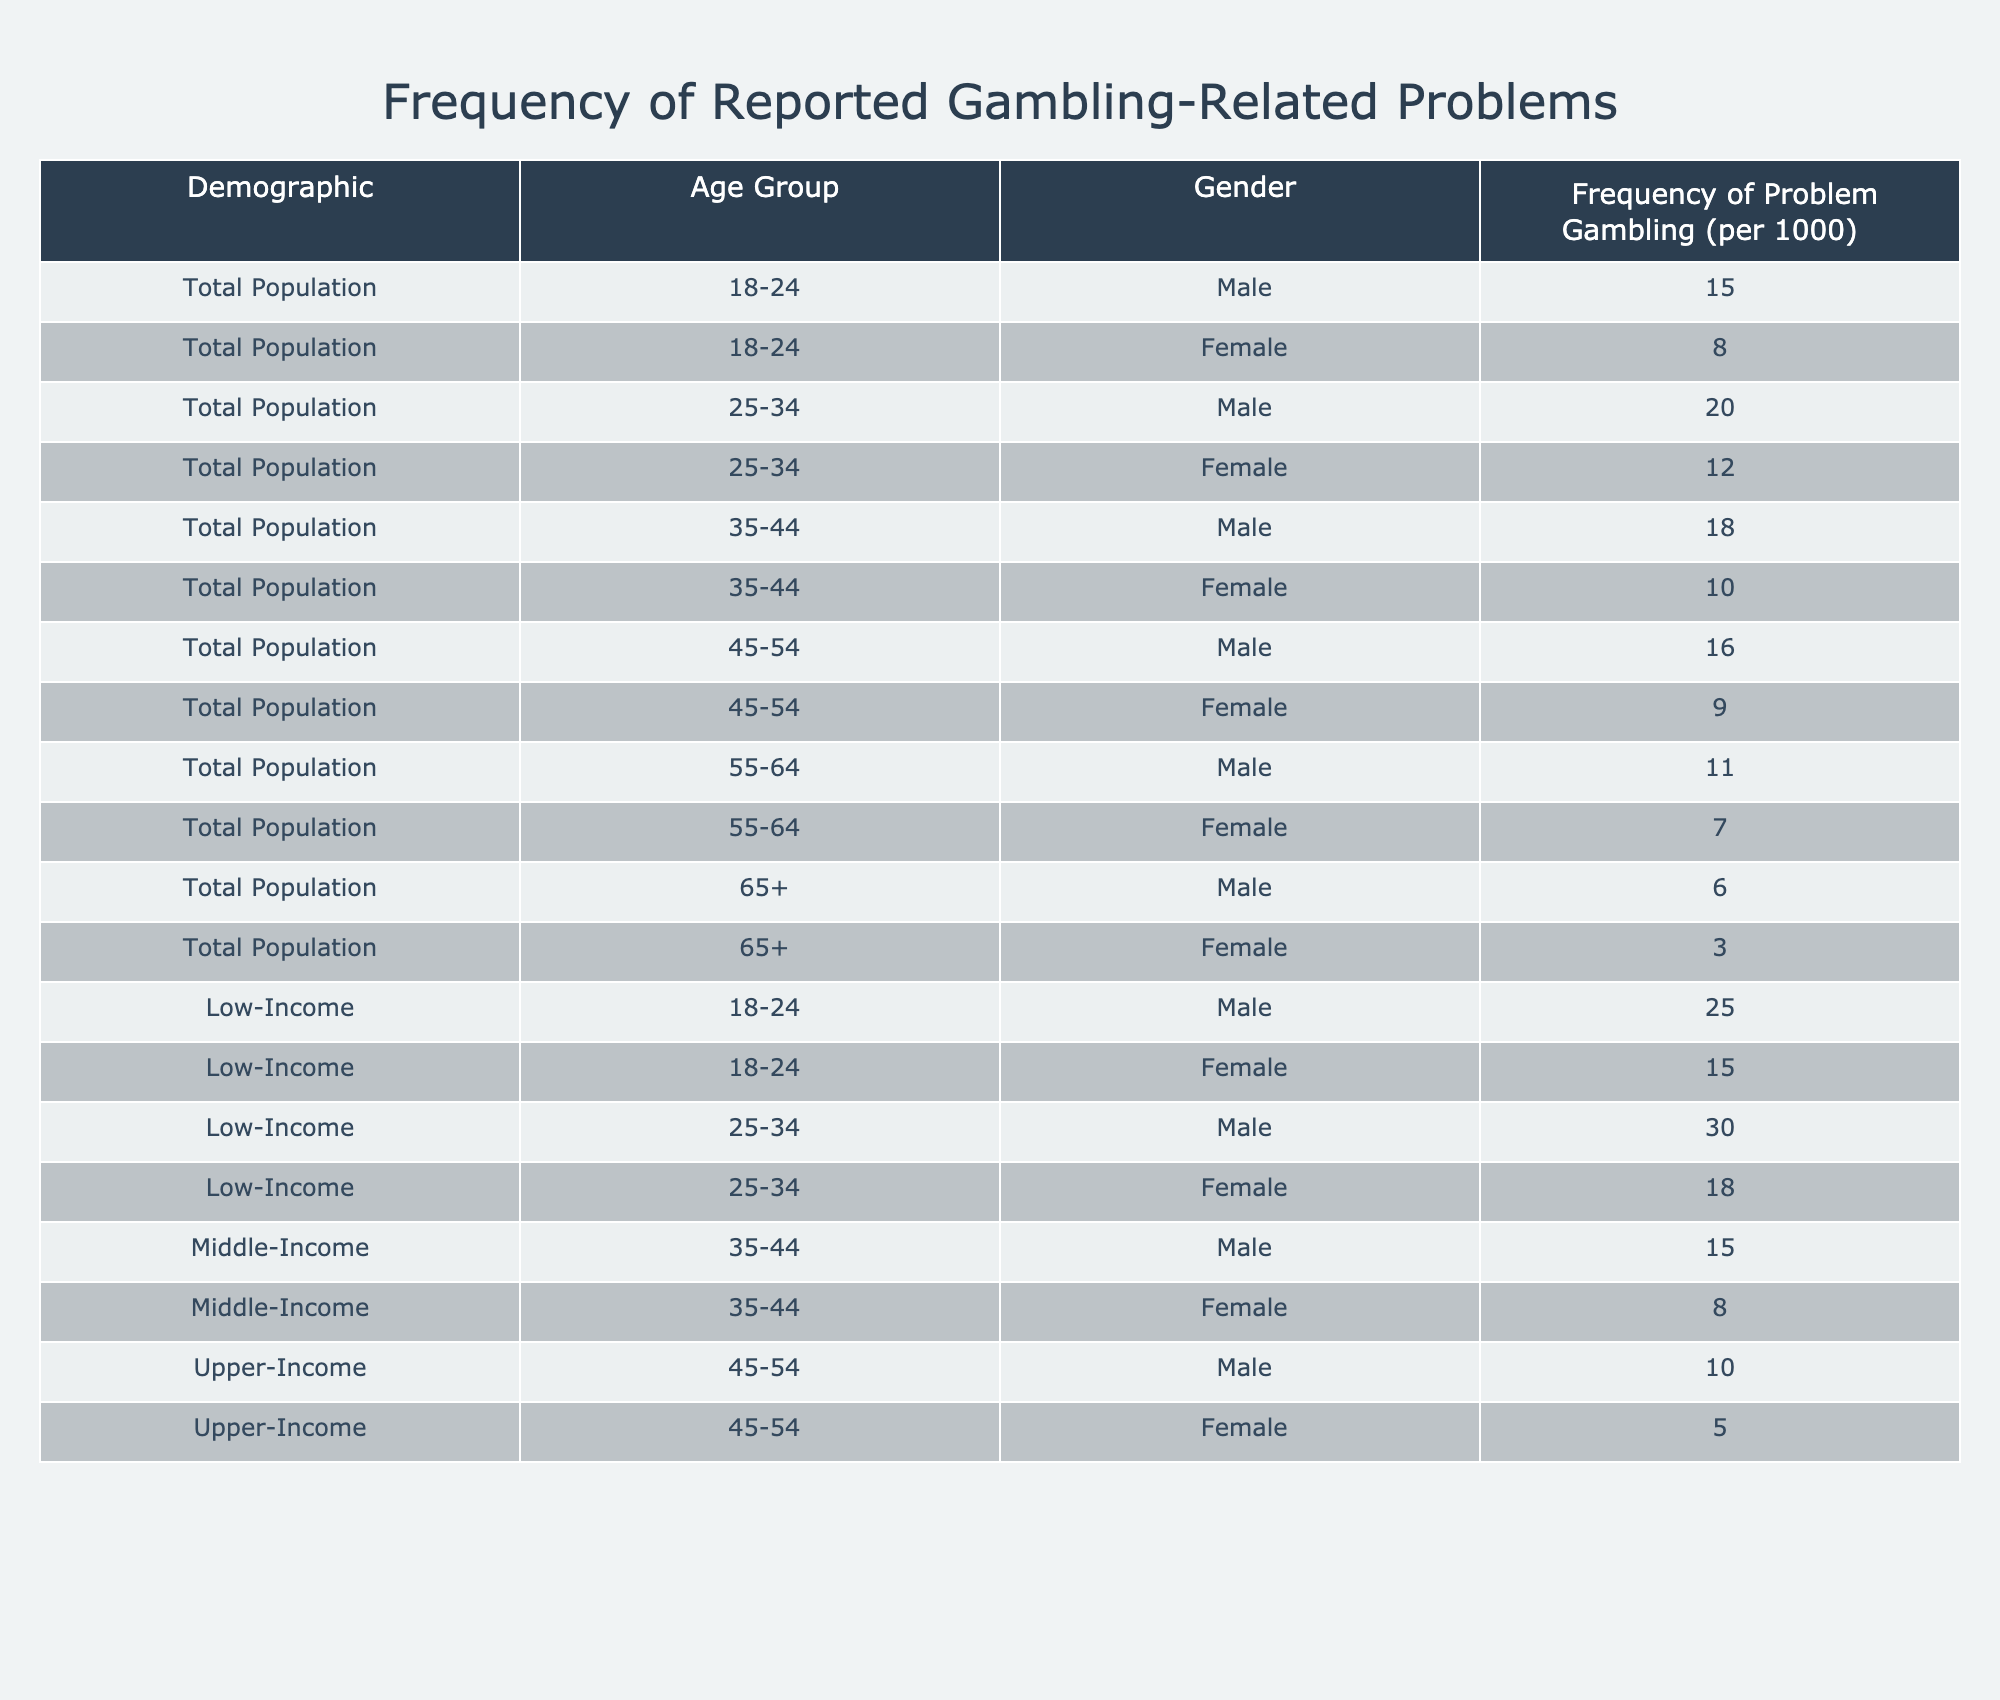What is the frequency of problem gambling among Low-Income females aged 25-34? From the table, the row corresponding to Low-Income females in the age group 25-34 shows a frequency of 18 problems per 1000 individuals.
Answer: 18 Which age group among the Total Population has the highest frequency of problem gambling for males? The age group 25-34 among the Total Population shows the highest frequency for males at 20 per 1000.
Answer: 25-34 What is the average frequency of problem gambling for Upper-Income males and females combined? For Upper-Income, the frequency for males is 10 and for females is 5. The average is calculated as (10 + 5) / 2 = 7.5.
Answer: 7.5 Is the frequency of problem gambling higher for Low-Income males or Low-Income females in the 18-24 age group? For Low-Income males aged 18-24, the frequency is 25, while for females it is 15. Thus, it is higher for males.
Answer: Yes What is the total frequency of problem gambling per 1000 for females aged 35-44 across all income levels? The frequencies for females aged 35-44 are: 10 (Total Population), 8 (Middle-Income), and no data for Low-Income and Upper-Income. Adding these gives a total of 10 + 8 = 18 per 1000.
Answer: 18 Which group has the lowest frequency of problem gambling among males aged 65 and older? The frequency for males aged 65+ is 6 per 1000, as shown in the provided data. It is the lowest among the male gender in that age category.
Answer: 6 If we categorize the problem gambling frequency by income level, which income group on average has the highest frequency? The averages are: Low-Income (average of 25 for 18-24, 30 for 25-34), Middle-Income (average of 15 for 35-44), Upper-Income (average of 7.5). Calculating gives Low-Income as the highest average with (25 + 30) / 2 = 27.5.
Answer: Low-Income How much higher is the frequency of problem gambling for males in the 25-34 age group compared to females in the same age group within the Total Population? Males in the 25-34 age group have a frequency of 20, while females have 12. The difference is 20 - 12 = 8, meaning males experience higher frequency by that amount.
Answer: 8 What is the frequency of problem gambling for males aged 55-64 in comparison to females of the same age? Males aged 55-64 have a frequency of 11, while females have 7. Therefore, the frequency is higher for males.
Answer: Males have higher frequency 